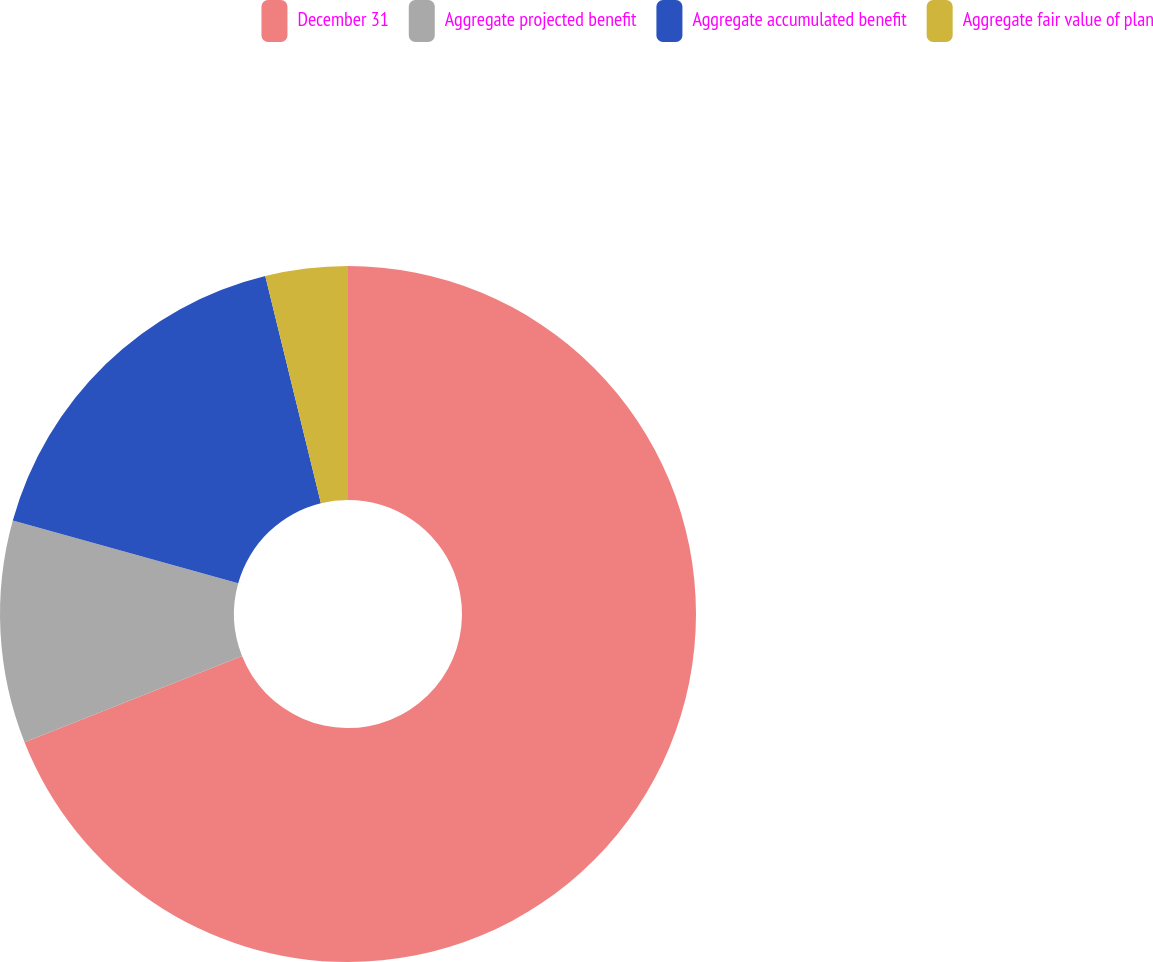Convert chart to OTSL. <chart><loc_0><loc_0><loc_500><loc_500><pie_chart><fcel>December 31<fcel>Aggregate projected benefit<fcel>Aggregate accumulated benefit<fcel>Aggregate fair value of plan<nl><fcel>68.99%<fcel>10.34%<fcel>16.85%<fcel>3.82%<nl></chart> 